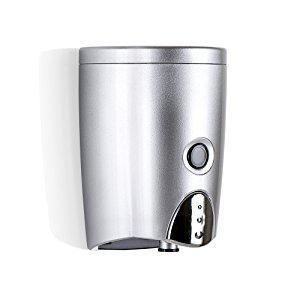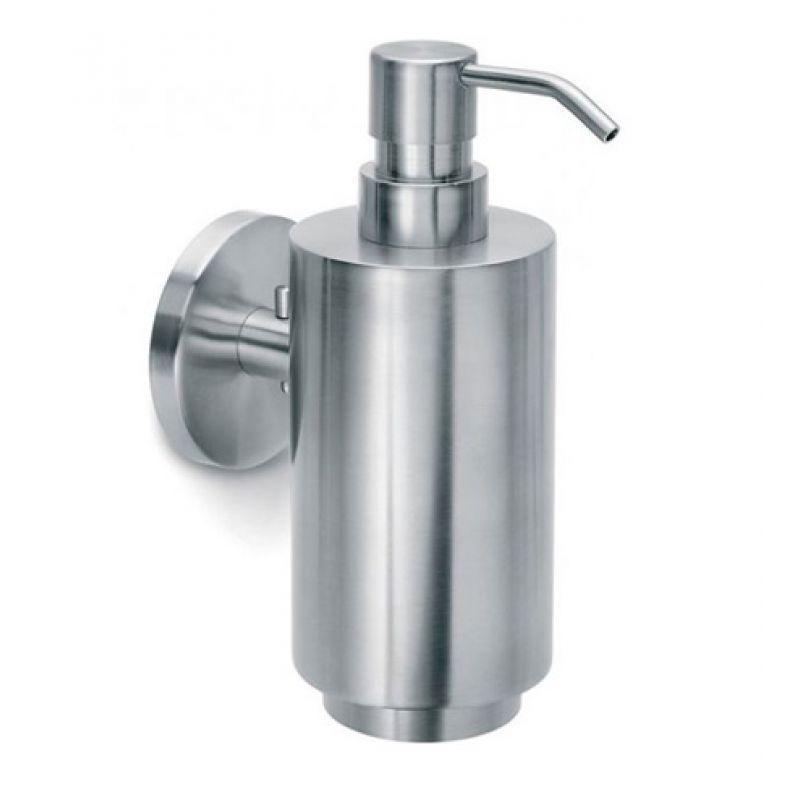The first image is the image on the left, the second image is the image on the right. Given the left and right images, does the statement "The dispenser in the image on the right has a round mounting bracket." hold true? Answer yes or no. Yes. 